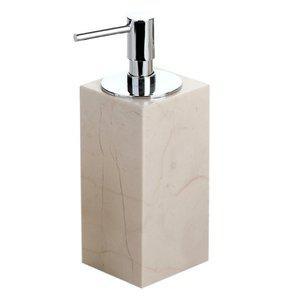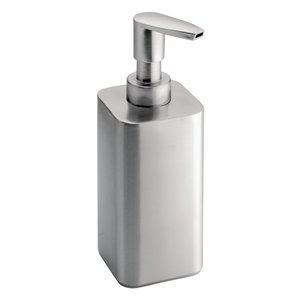The first image is the image on the left, the second image is the image on the right. Examine the images to the left and right. Is the description "The dispenser on the right is taller than the dispenser on the left." accurate? Answer yes or no. No. 